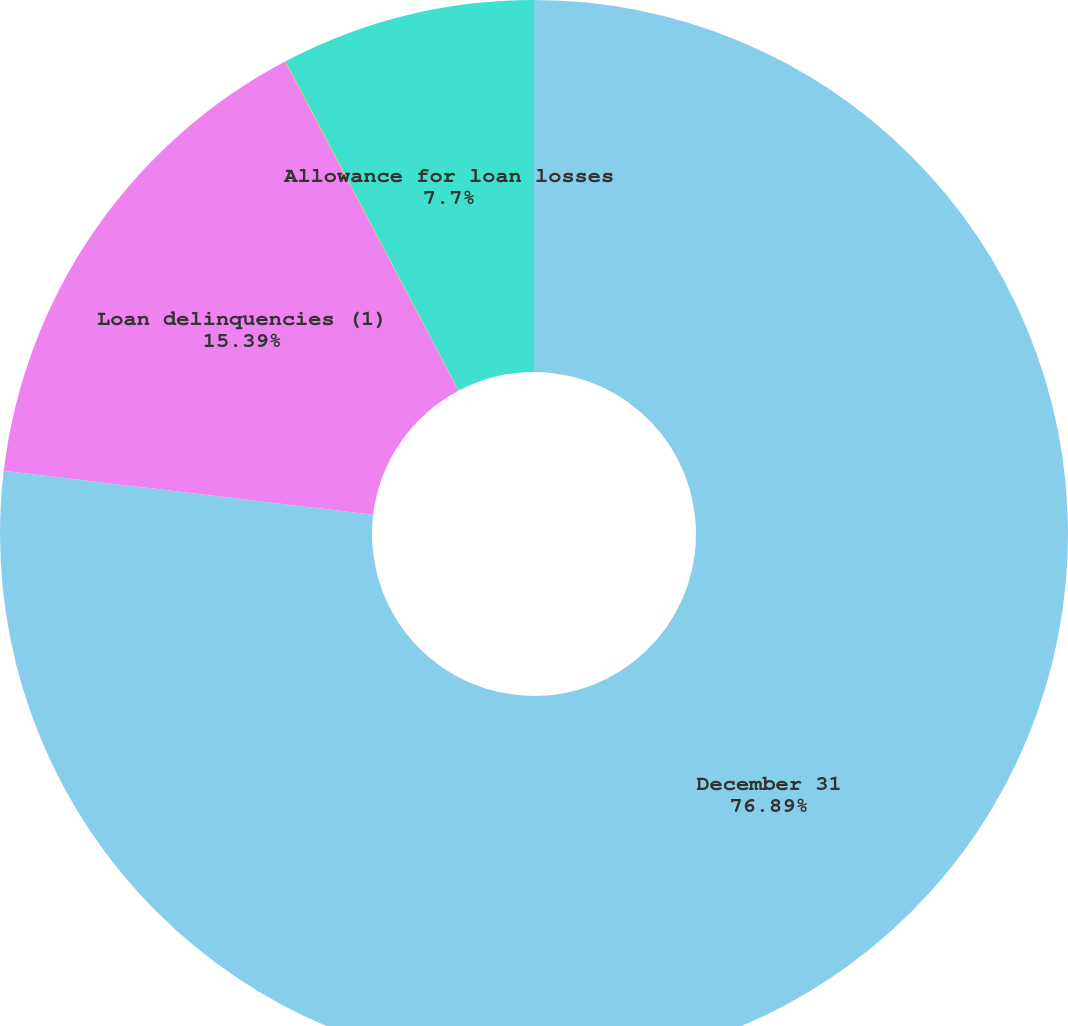Convert chart to OTSL. <chart><loc_0><loc_0><loc_500><loc_500><pie_chart><fcel>December 31<fcel>Loan delinquencies (1)<fcel>Nonaccrual loans<fcel>Allowance for loan losses<nl><fcel>76.89%<fcel>15.39%<fcel>0.02%<fcel>7.7%<nl></chart> 